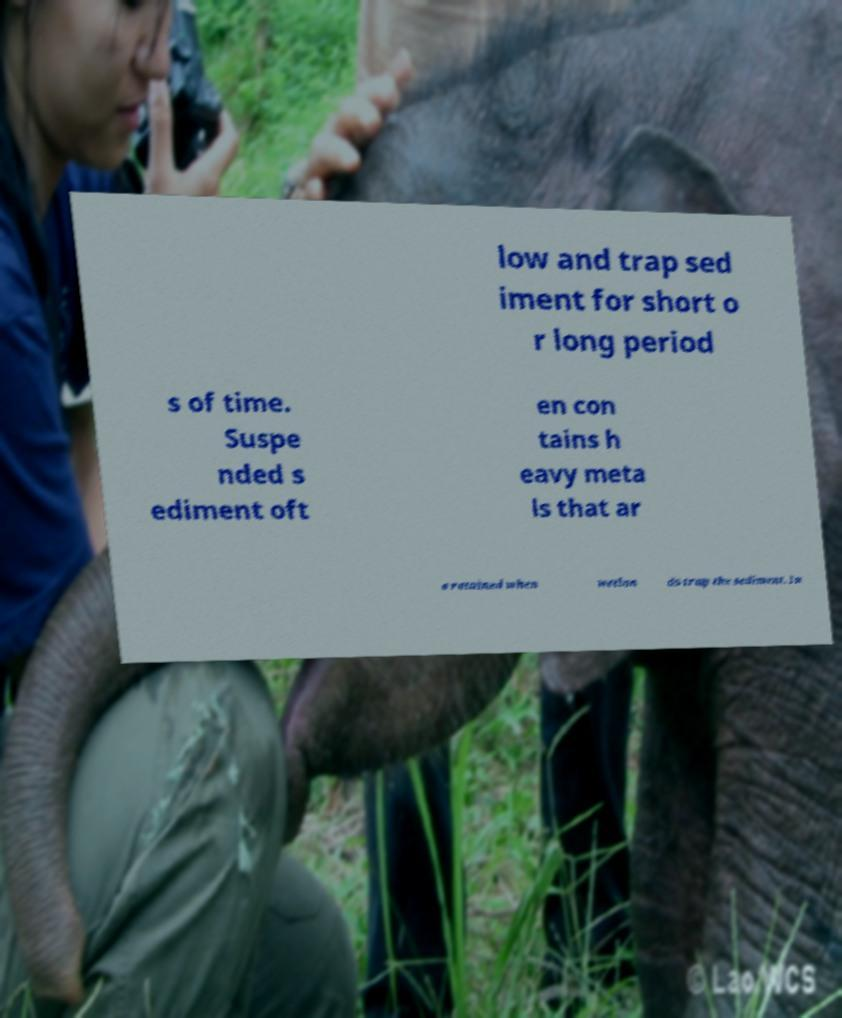Please read and relay the text visible in this image. What does it say? low and trap sed iment for short o r long period s of time. Suspe nded s ediment oft en con tains h eavy meta ls that ar e retained when wetlan ds trap the sediment. In 